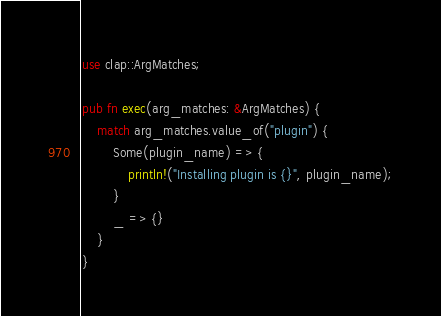Convert code to text. <code><loc_0><loc_0><loc_500><loc_500><_Rust_>use clap::ArgMatches;

pub fn exec(arg_matches: &ArgMatches) {
    match arg_matches.value_of("plugin") {
        Some(plugin_name) => {
            println!("Installing plugin is {}", plugin_name);
        }
        _ => {}
    }
}
</code> 